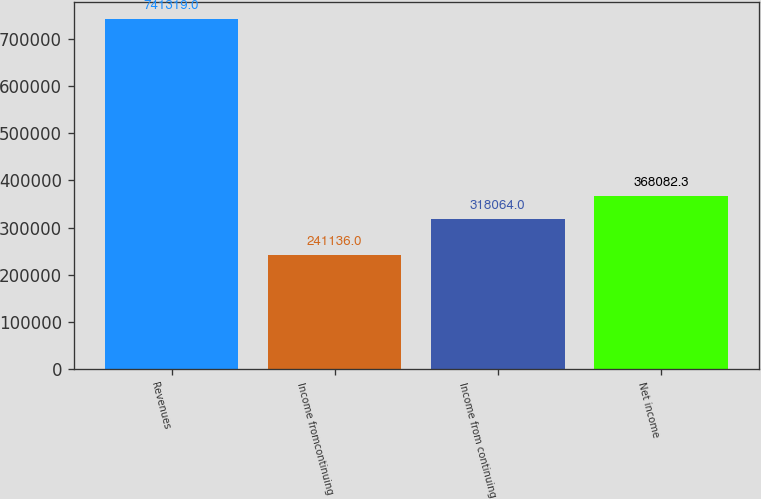<chart> <loc_0><loc_0><loc_500><loc_500><bar_chart><fcel>Revenues<fcel>Income fromcontinuing<fcel>Income from continuing<fcel>Net income<nl><fcel>741319<fcel>241136<fcel>318064<fcel>368082<nl></chart> 